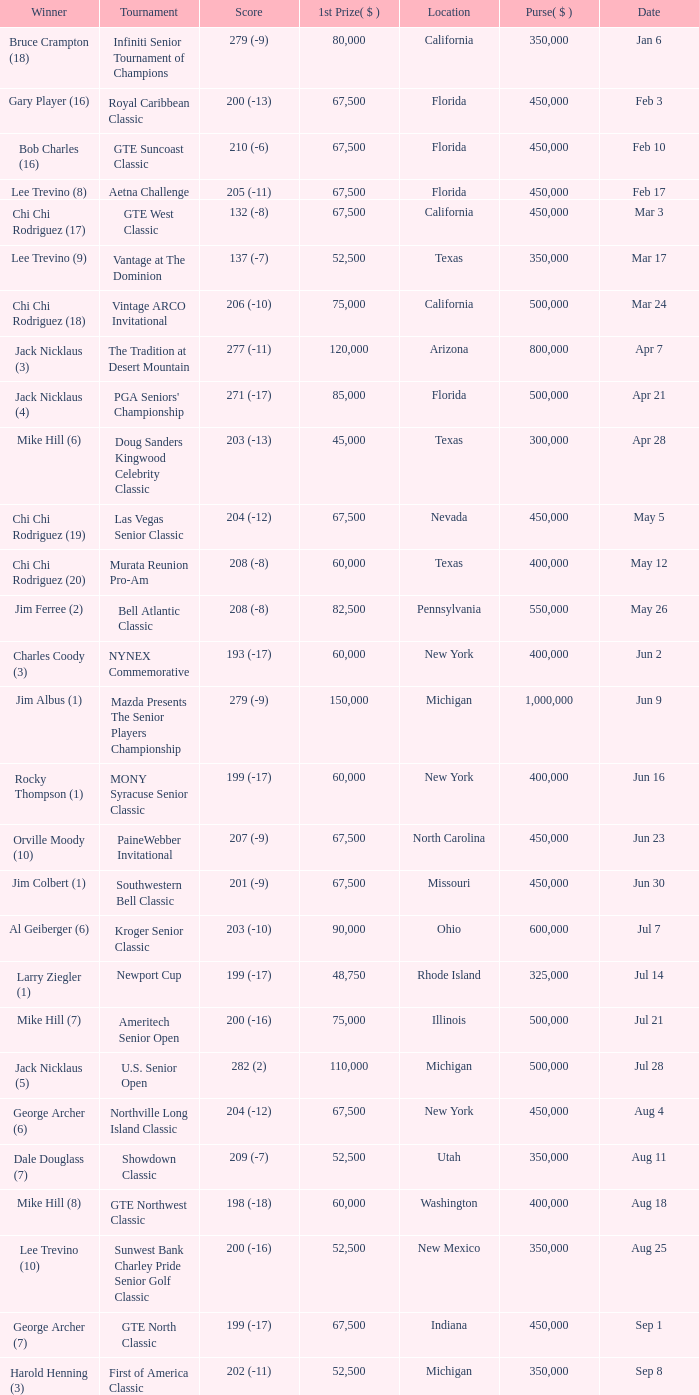Where was the security pacific senior classic? California. 